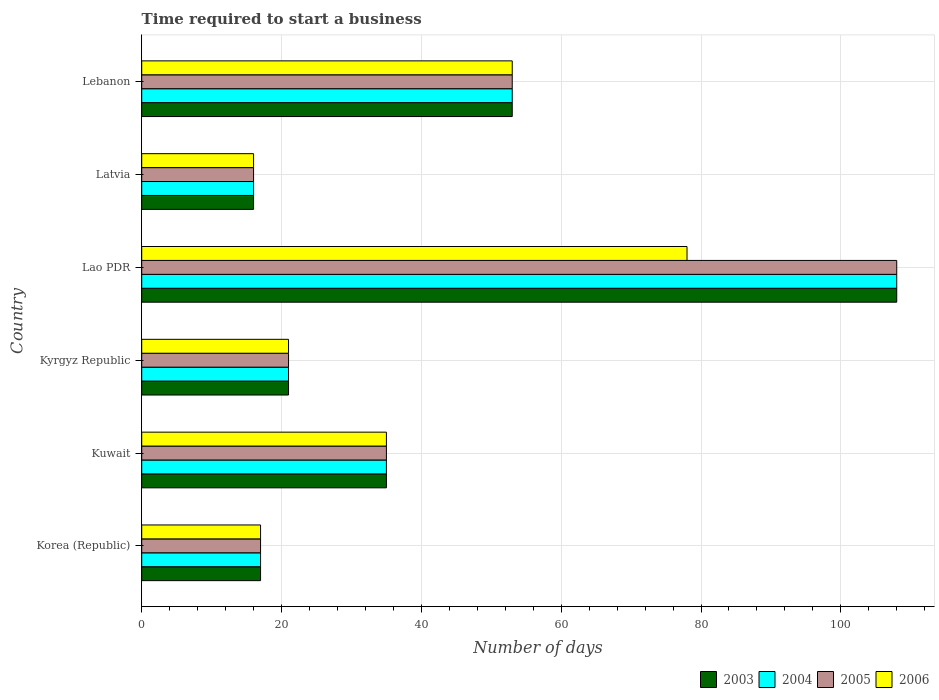How many different coloured bars are there?
Your answer should be very brief. 4. How many groups of bars are there?
Your response must be concise. 6. Are the number of bars on each tick of the Y-axis equal?
Your answer should be very brief. Yes. How many bars are there on the 2nd tick from the top?
Provide a succinct answer. 4. How many bars are there on the 4th tick from the bottom?
Your answer should be compact. 4. What is the label of the 3rd group of bars from the top?
Offer a terse response. Lao PDR. What is the number of days required to start a business in 2006 in Lao PDR?
Provide a short and direct response. 78. In which country was the number of days required to start a business in 2006 maximum?
Give a very brief answer. Lao PDR. In which country was the number of days required to start a business in 2004 minimum?
Make the answer very short. Latvia. What is the total number of days required to start a business in 2004 in the graph?
Keep it short and to the point. 250. What is the difference between the number of days required to start a business in 2004 in Lao PDR and the number of days required to start a business in 2005 in Kuwait?
Keep it short and to the point. 73. What is the average number of days required to start a business in 2004 per country?
Provide a succinct answer. 41.67. What is the difference between the number of days required to start a business in 2005 and number of days required to start a business in 2006 in Kuwait?
Provide a short and direct response. 0. What is the ratio of the number of days required to start a business in 2004 in Kyrgyz Republic to that in Latvia?
Give a very brief answer. 1.31. Is the number of days required to start a business in 2005 in Korea (Republic) less than that in Lebanon?
Offer a very short reply. Yes. Is the difference between the number of days required to start a business in 2005 in Kyrgyz Republic and Lao PDR greater than the difference between the number of days required to start a business in 2006 in Kyrgyz Republic and Lao PDR?
Your answer should be very brief. No. What is the difference between the highest and the second highest number of days required to start a business in 2003?
Provide a succinct answer. 55. What is the difference between the highest and the lowest number of days required to start a business in 2006?
Your answer should be very brief. 62. In how many countries, is the number of days required to start a business in 2004 greater than the average number of days required to start a business in 2004 taken over all countries?
Provide a short and direct response. 2. Is it the case that in every country, the sum of the number of days required to start a business in 2006 and number of days required to start a business in 2004 is greater than the sum of number of days required to start a business in 2005 and number of days required to start a business in 2003?
Your answer should be compact. No. What does the 2nd bar from the top in Lao PDR represents?
Keep it short and to the point. 2005. Is it the case that in every country, the sum of the number of days required to start a business in 2005 and number of days required to start a business in 2006 is greater than the number of days required to start a business in 2003?
Offer a very short reply. Yes. How many bars are there?
Give a very brief answer. 24. Are all the bars in the graph horizontal?
Provide a short and direct response. Yes. How many countries are there in the graph?
Provide a succinct answer. 6. What is the difference between two consecutive major ticks on the X-axis?
Your answer should be very brief. 20. Are the values on the major ticks of X-axis written in scientific E-notation?
Offer a terse response. No. Does the graph contain any zero values?
Make the answer very short. No. How many legend labels are there?
Give a very brief answer. 4. How are the legend labels stacked?
Your answer should be very brief. Horizontal. What is the title of the graph?
Ensure brevity in your answer.  Time required to start a business. What is the label or title of the X-axis?
Your response must be concise. Number of days. What is the Number of days in 2004 in Korea (Republic)?
Your response must be concise. 17. What is the Number of days in 2006 in Korea (Republic)?
Provide a short and direct response. 17. What is the Number of days of 2003 in Kuwait?
Ensure brevity in your answer.  35. What is the Number of days of 2005 in Kuwait?
Provide a short and direct response. 35. What is the Number of days in 2006 in Kuwait?
Make the answer very short. 35. What is the Number of days in 2005 in Kyrgyz Republic?
Offer a terse response. 21. What is the Number of days in 2003 in Lao PDR?
Your answer should be compact. 108. What is the Number of days of 2004 in Lao PDR?
Your answer should be compact. 108. What is the Number of days of 2005 in Lao PDR?
Offer a terse response. 108. What is the Number of days in 2006 in Latvia?
Give a very brief answer. 16. What is the Number of days in 2003 in Lebanon?
Your answer should be compact. 53. What is the Number of days of 2004 in Lebanon?
Your answer should be compact. 53. What is the Number of days in 2005 in Lebanon?
Your answer should be compact. 53. Across all countries, what is the maximum Number of days in 2003?
Make the answer very short. 108. Across all countries, what is the maximum Number of days in 2004?
Offer a terse response. 108. Across all countries, what is the maximum Number of days in 2005?
Provide a short and direct response. 108. Across all countries, what is the maximum Number of days of 2006?
Give a very brief answer. 78. What is the total Number of days in 2003 in the graph?
Ensure brevity in your answer.  250. What is the total Number of days of 2004 in the graph?
Your answer should be very brief. 250. What is the total Number of days of 2005 in the graph?
Offer a very short reply. 250. What is the total Number of days in 2006 in the graph?
Your answer should be very brief. 220. What is the difference between the Number of days of 2003 in Korea (Republic) and that in Kuwait?
Your answer should be compact. -18. What is the difference between the Number of days in 2003 in Korea (Republic) and that in Kyrgyz Republic?
Provide a succinct answer. -4. What is the difference between the Number of days of 2005 in Korea (Republic) and that in Kyrgyz Republic?
Provide a succinct answer. -4. What is the difference between the Number of days in 2006 in Korea (Republic) and that in Kyrgyz Republic?
Offer a very short reply. -4. What is the difference between the Number of days in 2003 in Korea (Republic) and that in Lao PDR?
Provide a short and direct response. -91. What is the difference between the Number of days of 2004 in Korea (Republic) and that in Lao PDR?
Your answer should be very brief. -91. What is the difference between the Number of days of 2005 in Korea (Republic) and that in Lao PDR?
Make the answer very short. -91. What is the difference between the Number of days in 2006 in Korea (Republic) and that in Lao PDR?
Your answer should be compact. -61. What is the difference between the Number of days of 2004 in Korea (Republic) and that in Latvia?
Your response must be concise. 1. What is the difference between the Number of days of 2005 in Korea (Republic) and that in Latvia?
Provide a succinct answer. 1. What is the difference between the Number of days in 2003 in Korea (Republic) and that in Lebanon?
Offer a very short reply. -36. What is the difference between the Number of days of 2004 in Korea (Republic) and that in Lebanon?
Offer a very short reply. -36. What is the difference between the Number of days of 2005 in Korea (Republic) and that in Lebanon?
Ensure brevity in your answer.  -36. What is the difference between the Number of days of 2006 in Korea (Republic) and that in Lebanon?
Keep it short and to the point. -36. What is the difference between the Number of days in 2004 in Kuwait and that in Kyrgyz Republic?
Offer a terse response. 14. What is the difference between the Number of days in 2005 in Kuwait and that in Kyrgyz Republic?
Your response must be concise. 14. What is the difference between the Number of days of 2006 in Kuwait and that in Kyrgyz Republic?
Provide a short and direct response. 14. What is the difference between the Number of days in 2003 in Kuwait and that in Lao PDR?
Provide a succinct answer. -73. What is the difference between the Number of days of 2004 in Kuwait and that in Lao PDR?
Provide a succinct answer. -73. What is the difference between the Number of days in 2005 in Kuwait and that in Lao PDR?
Give a very brief answer. -73. What is the difference between the Number of days in 2006 in Kuwait and that in Lao PDR?
Provide a short and direct response. -43. What is the difference between the Number of days in 2003 in Kuwait and that in Latvia?
Give a very brief answer. 19. What is the difference between the Number of days in 2004 in Kuwait and that in Latvia?
Give a very brief answer. 19. What is the difference between the Number of days of 2005 in Kuwait and that in Latvia?
Your response must be concise. 19. What is the difference between the Number of days of 2003 in Kuwait and that in Lebanon?
Give a very brief answer. -18. What is the difference between the Number of days of 2004 in Kuwait and that in Lebanon?
Make the answer very short. -18. What is the difference between the Number of days in 2006 in Kuwait and that in Lebanon?
Provide a short and direct response. -18. What is the difference between the Number of days of 2003 in Kyrgyz Republic and that in Lao PDR?
Your answer should be very brief. -87. What is the difference between the Number of days of 2004 in Kyrgyz Republic and that in Lao PDR?
Keep it short and to the point. -87. What is the difference between the Number of days in 2005 in Kyrgyz Republic and that in Lao PDR?
Ensure brevity in your answer.  -87. What is the difference between the Number of days of 2006 in Kyrgyz Republic and that in Lao PDR?
Offer a very short reply. -57. What is the difference between the Number of days in 2003 in Kyrgyz Republic and that in Latvia?
Provide a short and direct response. 5. What is the difference between the Number of days in 2005 in Kyrgyz Republic and that in Latvia?
Give a very brief answer. 5. What is the difference between the Number of days in 2003 in Kyrgyz Republic and that in Lebanon?
Ensure brevity in your answer.  -32. What is the difference between the Number of days in 2004 in Kyrgyz Republic and that in Lebanon?
Your answer should be compact. -32. What is the difference between the Number of days in 2005 in Kyrgyz Republic and that in Lebanon?
Your answer should be very brief. -32. What is the difference between the Number of days in 2006 in Kyrgyz Republic and that in Lebanon?
Make the answer very short. -32. What is the difference between the Number of days in 2003 in Lao PDR and that in Latvia?
Offer a terse response. 92. What is the difference between the Number of days in 2004 in Lao PDR and that in Latvia?
Provide a succinct answer. 92. What is the difference between the Number of days in 2005 in Lao PDR and that in Latvia?
Provide a succinct answer. 92. What is the difference between the Number of days in 2004 in Lao PDR and that in Lebanon?
Your answer should be compact. 55. What is the difference between the Number of days of 2006 in Lao PDR and that in Lebanon?
Your response must be concise. 25. What is the difference between the Number of days of 2003 in Latvia and that in Lebanon?
Give a very brief answer. -37. What is the difference between the Number of days of 2004 in Latvia and that in Lebanon?
Offer a terse response. -37. What is the difference between the Number of days in 2005 in Latvia and that in Lebanon?
Keep it short and to the point. -37. What is the difference between the Number of days of 2006 in Latvia and that in Lebanon?
Provide a succinct answer. -37. What is the difference between the Number of days in 2003 in Korea (Republic) and the Number of days in 2004 in Kuwait?
Keep it short and to the point. -18. What is the difference between the Number of days of 2003 in Korea (Republic) and the Number of days of 2005 in Kuwait?
Offer a very short reply. -18. What is the difference between the Number of days in 2004 in Korea (Republic) and the Number of days in 2005 in Kuwait?
Ensure brevity in your answer.  -18. What is the difference between the Number of days in 2004 in Korea (Republic) and the Number of days in 2006 in Kuwait?
Your answer should be compact. -18. What is the difference between the Number of days of 2003 in Korea (Republic) and the Number of days of 2005 in Kyrgyz Republic?
Keep it short and to the point. -4. What is the difference between the Number of days of 2004 in Korea (Republic) and the Number of days of 2005 in Kyrgyz Republic?
Provide a succinct answer. -4. What is the difference between the Number of days in 2003 in Korea (Republic) and the Number of days in 2004 in Lao PDR?
Give a very brief answer. -91. What is the difference between the Number of days of 2003 in Korea (Republic) and the Number of days of 2005 in Lao PDR?
Make the answer very short. -91. What is the difference between the Number of days of 2003 in Korea (Republic) and the Number of days of 2006 in Lao PDR?
Your answer should be very brief. -61. What is the difference between the Number of days in 2004 in Korea (Republic) and the Number of days in 2005 in Lao PDR?
Give a very brief answer. -91. What is the difference between the Number of days of 2004 in Korea (Republic) and the Number of days of 2006 in Lao PDR?
Your response must be concise. -61. What is the difference between the Number of days in 2005 in Korea (Republic) and the Number of days in 2006 in Lao PDR?
Give a very brief answer. -61. What is the difference between the Number of days of 2003 in Korea (Republic) and the Number of days of 2004 in Lebanon?
Your answer should be very brief. -36. What is the difference between the Number of days in 2003 in Korea (Republic) and the Number of days in 2005 in Lebanon?
Offer a very short reply. -36. What is the difference between the Number of days of 2003 in Korea (Republic) and the Number of days of 2006 in Lebanon?
Give a very brief answer. -36. What is the difference between the Number of days in 2004 in Korea (Republic) and the Number of days in 2005 in Lebanon?
Your answer should be very brief. -36. What is the difference between the Number of days of 2004 in Korea (Republic) and the Number of days of 2006 in Lebanon?
Provide a short and direct response. -36. What is the difference between the Number of days of 2005 in Korea (Republic) and the Number of days of 2006 in Lebanon?
Ensure brevity in your answer.  -36. What is the difference between the Number of days in 2003 in Kuwait and the Number of days in 2004 in Kyrgyz Republic?
Ensure brevity in your answer.  14. What is the difference between the Number of days in 2003 in Kuwait and the Number of days in 2005 in Kyrgyz Republic?
Ensure brevity in your answer.  14. What is the difference between the Number of days in 2003 in Kuwait and the Number of days in 2004 in Lao PDR?
Offer a very short reply. -73. What is the difference between the Number of days in 2003 in Kuwait and the Number of days in 2005 in Lao PDR?
Provide a short and direct response. -73. What is the difference between the Number of days of 2003 in Kuwait and the Number of days of 2006 in Lao PDR?
Make the answer very short. -43. What is the difference between the Number of days in 2004 in Kuwait and the Number of days in 2005 in Lao PDR?
Give a very brief answer. -73. What is the difference between the Number of days of 2004 in Kuwait and the Number of days of 2006 in Lao PDR?
Provide a succinct answer. -43. What is the difference between the Number of days in 2005 in Kuwait and the Number of days in 2006 in Lao PDR?
Provide a succinct answer. -43. What is the difference between the Number of days in 2003 in Kuwait and the Number of days in 2004 in Latvia?
Ensure brevity in your answer.  19. What is the difference between the Number of days of 2003 in Kuwait and the Number of days of 2005 in Latvia?
Keep it short and to the point. 19. What is the difference between the Number of days of 2003 in Kuwait and the Number of days of 2006 in Latvia?
Provide a succinct answer. 19. What is the difference between the Number of days in 2005 in Kuwait and the Number of days in 2006 in Latvia?
Ensure brevity in your answer.  19. What is the difference between the Number of days of 2003 in Kuwait and the Number of days of 2005 in Lebanon?
Give a very brief answer. -18. What is the difference between the Number of days in 2004 in Kuwait and the Number of days in 2005 in Lebanon?
Your answer should be very brief. -18. What is the difference between the Number of days in 2004 in Kuwait and the Number of days in 2006 in Lebanon?
Provide a short and direct response. -18. What is the difference between the Number of days in 2003 in Kyrgyz Republic and the Number of days in 2004 in Lao PDR?
Keep it short and to the point. -87. What is the difference between the Number of days of 2003 in Kyrgyz Republic and the Number of days of 2005 in Lao PDR?
Keep it short and to the point. -87. What is the difference between the Number of days of 2003 in Kyrgyz Republic and the Number of days of 2006 in Lao PDR?
Your answer should be very brief. -57. What is the difference between the Number of days in 2004 in Kyrgyz Republic and the Number of days in 2005 in Lao PDR?
Make the answer very short. -87. What is the difference between the Number of days of 2004 in Kyrgyz Republic and the Number of days of 2006 in Lao PDR?
Offer a terse response. -57. What is the difference between the Number of days in 2005 in Kyrgyz Republic and the Number of days in 2006 in Lao PDR?
Give a very brief answer. -57. What is the difference between the Number of days of 2003 in Kyrgyz Republic and the Number of days of 2004 in Latvia?
Offer a very short reply. 5. What is the difference between the Number of days of 2004 in Kyrgyz Republic and the Number of days of 2005 in Latvia?
Provide a succinct answer. 5. What is the difference between the Number of days in 2004 in Kyrgyz Republic and the Number of days in 2006 in Latvia?
Make the answer very short. 5. What is the difference between the Number of days in 2003 in Kyrgyz Republic and the Number of days in 2004 in Lebanon?
Offer a terse response. -32. What is the difference between the Number of days in 2003 in Kyrgyz Republic and the Number of days in 2005 in Lebanon?
Provide a succinct answer. -32. What is the difference between the Number of days in 2003 in Kyrgyz Republic and the Number of days in 2006 in Lebanon?
Offer a very short reply. -32. What is the difference between the Number of days in 2004 in Kyrgyz Republic and the Number of days in 2005 in Lebanon?
Ensure brevity in your answer.  -32. What is the difference between the Number of days of 2004 in Kyrgyz Republic and the Number of days of 2006 in Lebanon?
Offer a terse response. -32. What is the difference between the Number of days in 2005 in Kyrgyz Republic and the Number of days in 2006 in Lebanon?
Your answer should be compact. -32. What is the difference between the Number of days of 2003 in Lao PDR and the Number of days of 2004 in Latvia?
Ensure brevity in your answer.  92. What is the difference between the Number of days in 2003 in Lao PDR and the Number of days in 2005 in Latvia?
Offer a very short reply. 92. What is the difference between the Number of days of 2003 in Lao PDR and the Number of days of 2006 in Latvia?
Provide a succinct answer. 92. What is the difference between the Number of days of 2004 in Lao PDR and the Number of days of 2005 in Latvia?
Your response must be concise. 92. What is the difference between the Number of days of 2004 in Lao PDR and the Number of days of 2006 in Latvia?
Your answer should be very brief. 92. What is the difference between the Number of days of 2005 in Lao PDR and the Number of days of 2006 in Latvia?
Your answer should be very brief. 92. What is the difference between the Number of days in 2003 in Lao PDR and the Number of days in 2004 in Lebanon?
Ensure brevity in your answer.  55. What is the difference between the Number of days of 2004 in Lao PDR and the Number of days of 2005 in Lebanon?
Provide a short and direct response. 55. What is the difference between the Number of days of 2005 in Lao PDR and the Number of days of 2006 in Lebanon?
Your answer should be very brief. 55. What is the difference between the Number of days of 2003 in Latvia and the Number of days of 2004 in Lebanon?
Offer a very short reply. -37. What is the difference between the Number of days of 2003 in Latvia and the Number of days of 2005 in Lebanon?
Ensure brevity in your answer.  -37. What is the difference between the Number of days of 2003 in Latvia and the Number of days of 2006 in Lebanon?
Your answer should be very brief. -37. What is the difference between the Number of days in 2004 in Latvia and the Number of days in 2005 in Lebanon?
Your answer should be compact. -37. What is the difference between the Number of days of 2004 in Latvia and the Number of days of 2006 in Lebanon?
Ensure brevity in your answer.  -37. What is the difference between the Number of days in 2005 in Latvia and the Number of days in 2006 in Lebanon?
Provide a short and direct response. -37. What is the average Number of days in 2003 per country?
Offer a terse response. 41.67. What is the average Number of days of 2004 per country?
Give a very brief answer. 41.67. What is the average Number of days of 2005 per country?
Give a very brief answer. 41.67. What is the average Number of days of 2006 per country?
Your answer should be compact. 36.67. What is the difference between the Number of days in 2003 and Number of days in 2004 in Korea (Republic)?
Your response must be concise. 0. What is the difference between the Number of days of 2003 and Number of days of 2005 in Korea (Republic)?
Provide a short and direct response. 0. What is the difference between the Number of days in 2005 and Number of days in 2006 in Korea (Republic)?
Your answer should be very brief. 0. What is the difference between the Number of days of 2003 and Number of days of 2004 in Kuwait?
Ensure brevity in your answer.  0. What is the difference between the Number of days in 2003 and Number of days in 2005 in Kuwait?
Provide a short and direct response. 0. What is the difference between the Number of days in 2003 and Number of days in 2006 in Kuwait?
Make the answer very short. 0. What is the difference between the Number of days in 2003 and Number of days in 2005 in Kyrgyz Republic?
Your answer should be very brief. 0. What is the difference between the Number of days of 2004 and Number of days of 2006 in Kyrgyz Republic?
Your answer should be very brief. 0. What is the difference between the Number of days in 2003 and Number of days in 2006 in Lao PDR?
Give a very brief answer. 30. What is the difference between the Number of days of 2004 and Number of days of 2005 in Lao PDR?
Your answer should be very brief. 0. What is the difference between the Number of days in 2003 and Number of days in 2004 in Latvia?
Provide a succinct answer. 0. What is the difference between the Number of days in 2003 and Number of days in 2005 in Latvia?
Give a very brief answer. 0. What is the difference between the Number of days in 2003 and Number of days in 2006 in Lebanon?
Your answer should be very brief. 0. What is the difference between the Number of days of 2004 and Number of days of 2005 in Lebanon?
Give a very brief answer. 0. What is the difference between the Number of days of 2005 and Number of days of 2006 in Lebanon?
Offer a terse response. 0. What is the ratio of the Number of days in 2003 in Korea (Republic) to that in Kuwait?
Offer a very short reply. 0.49. What is the ratio of the Number of days in 2004 in Korea (Republic) to that in Kuwait?
Your answer should be compact. 0.49. What is the ratio of the Number of days in 2005 in Korea (Republic) to that in Kuwait?
Offer a terse response. 0.49. What is the ratio of the Number of days in 2006 in Korea (Republic) to that in Kuwait?
Give a very brief answer. 0.49. What is the ratio of the Number of days in 2003 in Korea (Republic) to that in Kyrgyz Republic?
Provide a short and direct response. 0.81. What is the ratio of the Number of days in 2004 in Korea (Republic) to that in Kyrgyz Republic?
Provide a short and direct response. 0.81. What is the ratio of the Number of days in 2005 in Korea (Republic) to that in Kyrgyz Republic?
Your answer should be very brief. 0.81. What is the ratio of the Number of days of 2006 in Korea (Republic) to that in Kyrgyz Republic?
Your answer should be very brief. 0.81. What is the ratio of the Number of days of 2003 in Korea (Republic) to that in Lao PDR?
Keep it short and to the point. 0.16. What is the ratio of the Number of days in 2004 in Korea (Republic) to that in Lao PDR?
Keep it short and to the point. 0.16. What is the ratio of the Number of days of 2005 in Korea (Republic) to that in Lao PDR?
Provide a succinct answer. 0.16. What is the ratio of the Number of days in 2006 in Korea (Republic) to that in Lao PDR?
Your response must be concise. 0.22. What is the ratio of the Number of days of 2003 in Korea (Republic) to that in Latvia?
Your response must be concise. 1.06. What is the ratio of the Number of days in 2004 in Korea (Republic) to that in Latvia?
Your response must be concise. 1.06. What is the ratio of the Number of days of 2006 in Korea (Republic) to that in Latvia?
Provide a succinct answer. 1.06. What is the ratio of the Number of days in 2003 in Korea (Republic) to that in Lebanon?
Give a very brief answer. 0.32. What is the ratio of the Number of days of 2004 in Korea (Republic) to that in Lebanon?
Provide a succinct answer. 0.32. What is the ratio of the Number of days in 2005 in Korea (Republic) to that in Lebanon?
Offer a very short reply. 0.32. What is the ratio of the Number of days of 2006 in Korea (Republic) to that in Lebanon?
Your response must be concise. 0.32. What is the ratio of the Number of days of 2003 in Kuwait to that in Kyrgyz Republic?
Your response must be concise. 1.67. What is the ratio of the Number of days in 2005 in Kuwait to that in Kyrgyz Republic?
Your answer should be compact. 1.67. What is the ratio of the Number of days in 2006 in Kuwait to that in Kyrgyz Republic?
Your answer should be compact. 1.67. What is the ratio of the Number of days in 2003 in Kuwait to that in Lao PDR?
Provide a short and direct response. 0.32. What is the ratio of the Number of days of 2004 in Kuwait to that in Lao PDR?
Your response must be concise. 0.32. What is the ratio of the Number of days of 2005 in Kuwait to that in Lao PDR?
Your answer should be very brief. 0.32. What is the ratio of the Number of days of 2006 in Kuwait to that in Lao PDR?
Your answer should be very brief. 0.45. What is the ratio of the Number of days in 2003 in Kuwait to that in Latvia?
Keep it short and to the point. 2.19. What is the ratio of the Number of days in 2004 in Kuwait to that in Latvia?
Provide a succinct answer. 2.19. What is the ratio of the Number of days in 2005 in Kuwait to that in Latvia?
Your response must be concise. 2.19. What is the ratio of the Number of days of 2006 in Kuwait to that in Latvia?
Provide a succinct answer. 2.19. What is the ratio of the Number of days in 2003 in Kuwait to that in Lebanon?
Provide a succinct answer. 0.66. What is the ratio of the Number of days of 2004 in Kuwait to that in Lebanon?
Your response must be concise. 0.66. What is the ratio of the Number of days in 2005 in Kuwait to that in Lebanon?
Make the answer very short. 0.66. What is the ratio of the Number of days of 2006 in Kuwait to that in Lebanon?
Offer a very short reply. 0.66. What is the ratio of the Number of days in 2003 in Kyrgyz Republic to that in Lao PDR?
Keep it short and to the point. 0.19. What is the ratio of the Number of days in 2004 in Kyrgyz Republic to that in Lao PDR?
Provide a short and direct response. 0.19. What is the ratio of the Number of days in 2005 in Kyrgyz Republic to that in Lao PDR?
Ensure brevity in your answer.  0.19. What is the ratio of the Number of days in 2006 in Kyrgyz Republic to that in Lao PDR?
Provide a succinct answer. 0.27. What is the ratio of the Number of days of 2003 in Kyrgyz Republic to that in Latvia?
Make the answer very short. 1.31. What is the ratio of the Number of days of 2004 in Kyrgyz Republic to that in Latvia?
Your answer should be very brief. 1.31. What is the ratio of the Number of days in 2005 in Kyrgyz Republic to that in Latvia?
Offer a very short reply. 1.31. What is the ratio of the Number of days in 2006 in Kyrgyz Republic to that in Latvia?
Your answer should be compact. 1.31. What is the ratio of the Number of days of 2003 in Kyrgyz Republic to that in Lebanon?
Your answer should be very brief. 0.4. What is the ratio of the Number of days in 2004 in Kyrgyz Republic to that in Lebanon?
Keep it short and to the point. 0.4. What is the ratio of the Number of days of 2005 in Kyrgyz Republic to that in Lebanon?
Offer a very short reply. 0.4. What is the ratio of the Number of days of 2006 in Kyrgyz Republic to that in Lebanon?
Make the answer very short. 0.4. What is the ratio of the Number of days in 2003 in Lao PDR to that in Latvia?
Keep it short and to the point. 6.75. What is the ratio of the Number of days in 2004 in Lao PDR to that in Latvia?
Offer a terse response. 6.75. What is the ratio of the Number of days in 2005 in Lao PDR to that in Latvia?
Your response must be concise. 6.75. What is the ratio of the Number of days in 2006 in Lao PDR to that in Latvia?
Keep it short and to the point. 4.88. What is the ratio of the Number of days in 2003 in Lao PDR to that in Lebanon?
Give a very brief answer. 2.04. What is the ratio of the Number of days of 2004 in Lao PDR to that in Lebanon?
Give a very brief answer. 2.04. What is the ratio of the Number of days in 2005 in Lao PDR to that in Lebanon?
Provide a short and direct response. 2.04. What is the ratio of the Number of days in 2006 in Lao PDR to that in Lebanon?
Provide a short and direct response. 1.47. What is the ratio of the Number of days in 2003 in Latvia to that in Lebanon?
Keep it short and to the point. 0.3. What is the ratio of the Number of days in 2004 in Latvia to that in Lebanon?
Ensure brevity in your answer.  0.3. What is the ratio of the Number of days in 2005 in Latvia to that in Lebanon?
Offer a very short reply. 0.3. What is the ratio of the Number of days of 2006 in Latvia to that in Lebanon?
Make the answer very short. 0.3. What is the difference between the highest and the second highest Number of days of 2003?
Keep it short and to the point. 55. What is the difference between the highest and the second highest Number of days in 2006?
Your answer should be compact. 25. What is the difference between the highest and the lowest Number of days of 2003?
Your response must be concise. 92. What is the difference between the highest and the lowest Number of days in 2004?
Make the answer very short. 92. What is the difference between the highest and the lowest Number of days in 2005?
Provide a short and direct response. 92. What is the difference between the highest and the lowest Number of days in 2006?
Give a very brief answer. 62. 